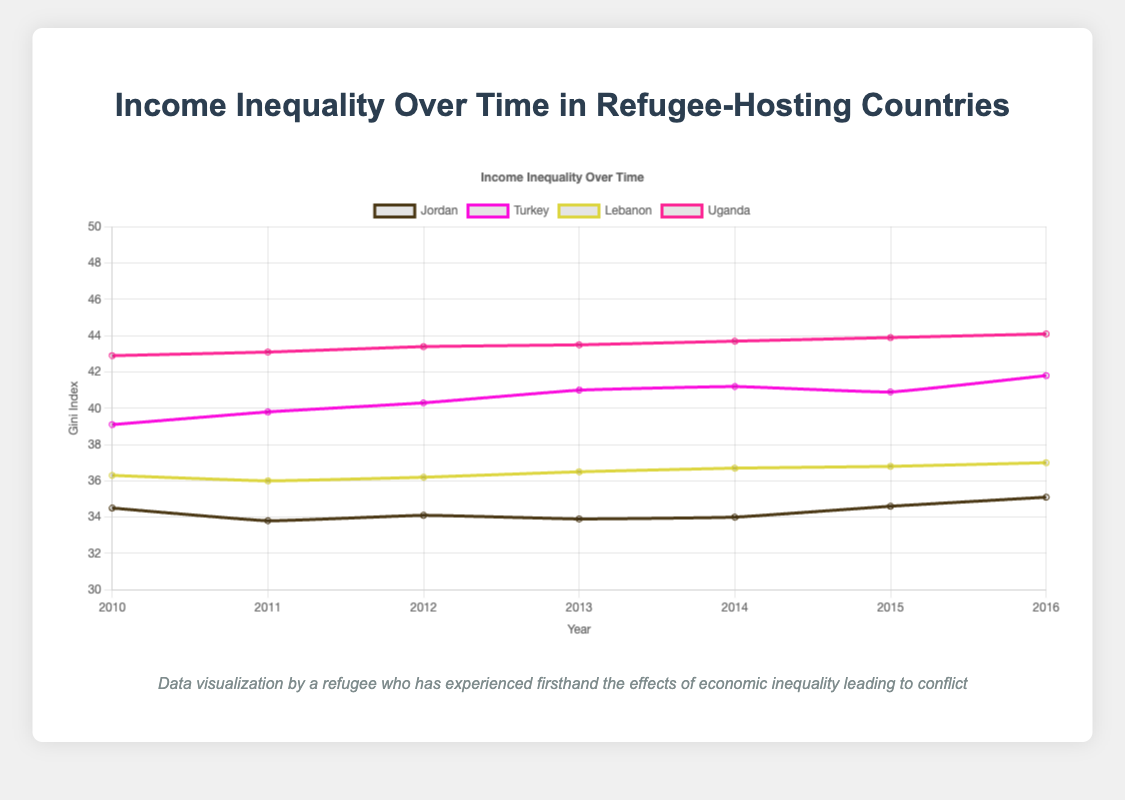What is the trend of the Gini index for Jordan from 2010 to 2016? Observing the line for Jordan in the line chart, it starts at 34.5 in 2010, fluctuates slightly over the years with minor ups and downs, and ends at 35.1 in 2016, indicating an overall increasing trend.
Answer: Increasing Which country had the highest Gini index in 2016? By examining the Gini indices for all countries in 2016, Uganda has the highest value at 44.1.
Answer: Uganda Compare the Gini index trends for Turkey and Lebanon. Which country shows a more significant increase from 2010 to 2016? Turkey's Gini index increases from 39.1 in 2010 to 41.8 in 2016, showing a rise of 2.7 points. Lebanon's Gini index increases from 36.3 in 2010 to 37.0 in 2016, showing a rise of 0.7 points. Therefore, Turkey shows a more significant increase.
Answer: Turkey What is the average Gini index of Jordan between 2010 and 2016? Jordan's Gini indices for the years are: 34.5, 33.8, 34.1, 33.9, 34.0, 34.6, 35.1. Summing these up gives 240.0, and dividing by 7 (number of years) gives an average of approximately 34.3.
Answer: 34.3 Which country had the most stable Gini index (with the least variation) between 2010 and 2016? Examining the Gini indices for each country over the years:
- Jordan: 34.5, 33.8, 34.1, 33.9, 34.0, 34.6, 35.1 (range 33.8 to 35.1)
- Turkey: 39.1, 39.8, 40.3, 41.0, 41.2, 40.9, 41.8 (range 39.1 to 41.8)
- Lebanon: 36.3, 36.0, 36.2, 36.5, 36.7, 36.8, 37.0 (range 36.0 to 37.0)
- Uganda: 42.9, 43.1, 43.4, 43.5, 43.7, 43.9, 44.1 (range 42.9 to 44.1)
Lebanon shows the least variation with a range of 36.0 to 37.0.
Answer: Lebanon In which year did Kenya experience the highest Gini index, and what was the value? By examining the line chart for Kenya, observe the highest point at year 2016, with a Gini index value of 44.1.
Answer: 2016, 44.1 Which country had the lowest Gini index in 2011? By looking at the data points for 2011 in the chart, Jordan has the lowest Gini index at 33.8.
Answer: Jordan Calculate the difference between the highest and lowest Gini indices for Uganda between 2010 and 2016. Uganda's Gini indices from 2010 to 2016 are 42.9, 43.1, 43.4, 43.5, 43.7, 43.9, 44.1. The highest value is 44.1 and the lowest is 42.9. Their difference is 44.1 - 42.9 = 1.2.
Answer: 1.2 Identify the year when Lebanon's Gini index surpassed 36.5 for the first time. Observing Lebanon's Gini index values, it first surpasses 36.5 in 2014 with a value of 36.7.
Answer: 2014 